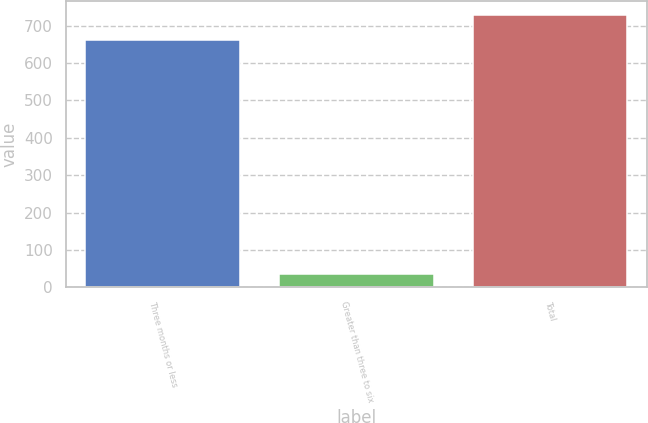Convert chart. <chart><loc_0><loc_0><loc_500><loc_500><bar_chart><fcel>Three months or less<fcel>Greater than three to six<fcel>Total<nl><fcel>661<fcel>37<fcel>729.2<nl></chart> 